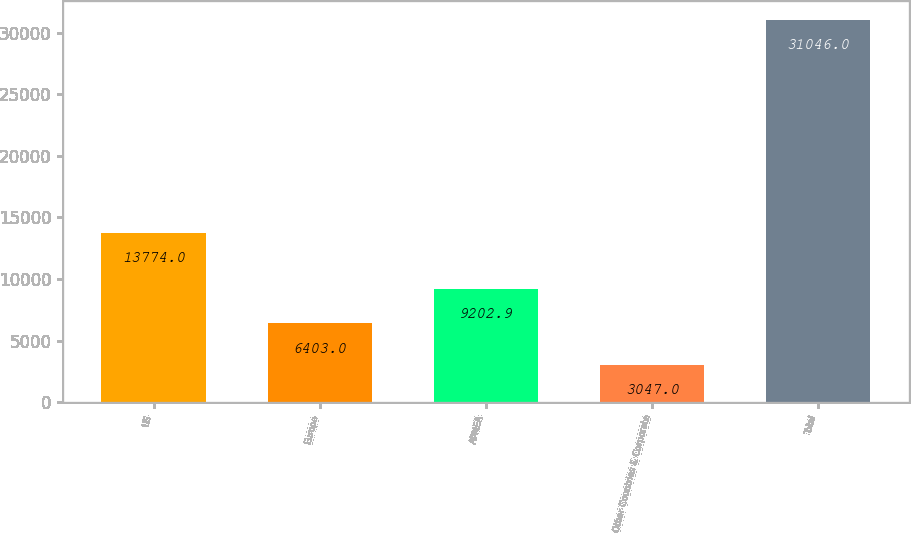<chart> <loc_0><loc_0><loc_500><loc_500><bar_chart><fcel>US<fcel>Europe<fcel>APMEA<fcel>Other Countries & Corporate<fcel>Total<nl><fcel>13774<fcel>6403<fcel>9202.9<fcel>3047<fcel>31046<nl></chart> 